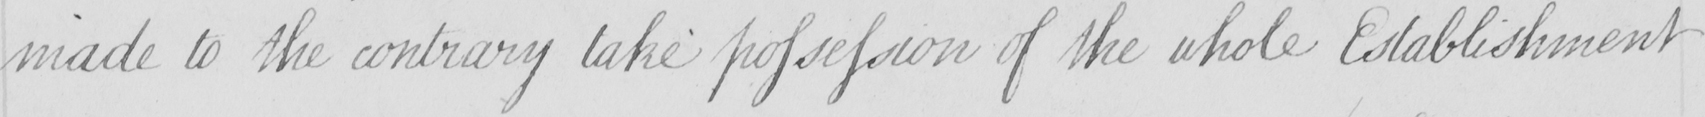Please provide the text content of this handwritten line. made to the contrary take possession of the whole Establishment 